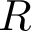Convert formula to latex. <formula><loc_0><loc_0><loc_500><loc_500>R</formula> 